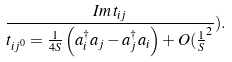<formula> <loc_0><loc_0><loc_500><loc_500>\frac { \sl I m \, t _ { i j } } { t _ { i j ^ { 0 } } = \frac { 1 } { 4 S } \left ( a _ { i } ^ { \dagger } a _ { j } - a _ { j } ^ { \dagger } a _ { i } \right ) + O ( \frac { 1 } S ^ { 2 } } ) .</formula> 